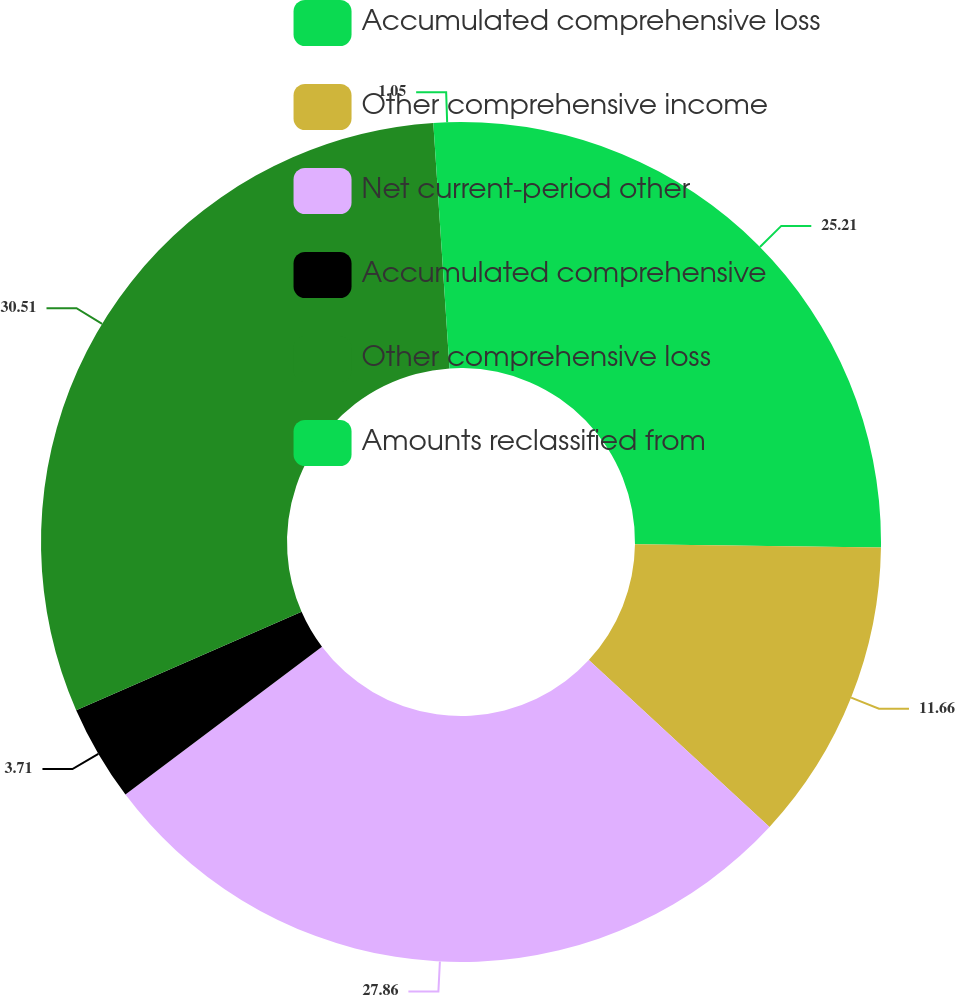Convert chart. <chart><loc_0><loc_0><loc_500><loc_500><pie_chart><fcel>Accumulated comprehensive loss<fcel>Other comprehensive income<fcel>Net current-period other<fcel>Accumulated comprehensive<fcel>Other comprehensive loss<fcel>Amounts reclassified from<nl><fcel>25.21%<fcel>11.66%<fcel>27.86%<fcel>3.71%<fcel>30.51%<fcel>1.05%<nl></chart> 